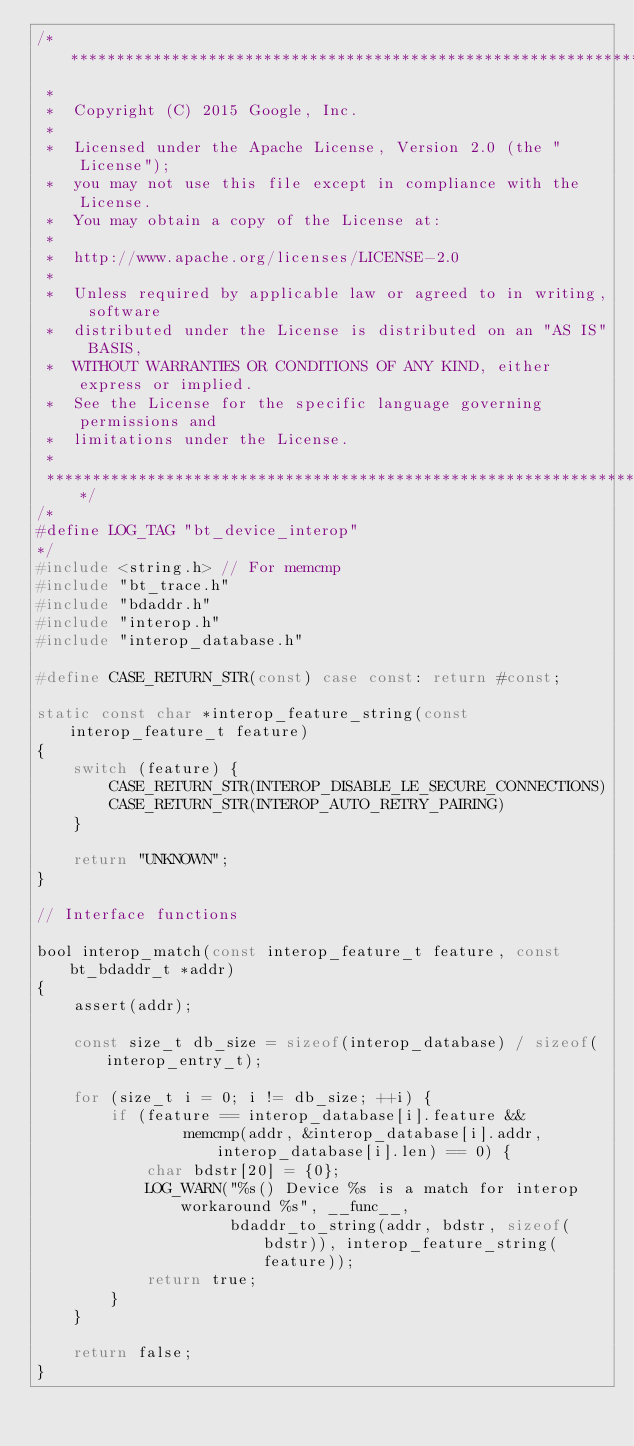Convert code to text. <code><loc_0><loc_0><loc_500><loc_500><_C_>/******************************************************************************
 *
 *  Copyright (C) 2015 Google, Inc.
 *
 *  Licensed under the Apache License, Version 2.0 (the "License");
 *  you may not use this file except in compliance with the License.
 *  You may obtain a copy of the License at:
 *
 *  http://www.apache.org/licenses/LICENSE-2.0
 *
 *  Unless required by applicable law or agreed to in writing, software
 *  distributed under the License is distributed on an "AS IS" BASIS,
 *  WITHOUT WARRANTIES OR CONDITIONS OF ANY KIND, either express or implied.
 *  See the License for the specific language governing permissions and
 *  limitations under the License.
 *
 ******************************************************************************/
/*
#define LOG_TAG "bt_device_interop"
*/
#include <string.h> // For memcmp
#include "bt_trace.h"
#include "bdaddr.h"
#include "interop.h"
#include "interop_database.h"

#define CASE_RETURN_STR(const) case const: return #const;

static const char *interop_feature_string(const interop_feature_t feature)
{
    switch (feature) {
        CASE_RETURN_STR(INTEROP_DISABLE_LE_SECURE_CONNECTIONS)
        CASE_RETURN_STR(INTEROP_AUTO_RETRY_PAIRING)
    }

    return "UNKNOWN";
}

// Interface functions

bool interop_match(const interop_feature_t feature, const bt_bdaddr_t *addr)
{
    assert(addr);

    const size_t db_size = sizeof(interop_database) / sizeof(interop_entry_t);

    for (size_t i = 0; i != db_size; ++i) {
        if (feature == interop_database[i].feature &&
                memcmp(addr, &interop_database[i].addr, interop_database[i].len) == 0) {
            char bdstr[20] = {0};
            LOG_WARN("%s() Device %s is a match for interop workaround %s", __func__,
                     bdaddr_to_string(addr, bdstr, sizeof(bdstr)), interop_feature_string(feature));
            return true;
        }
    }

    return false;
}
</code> 